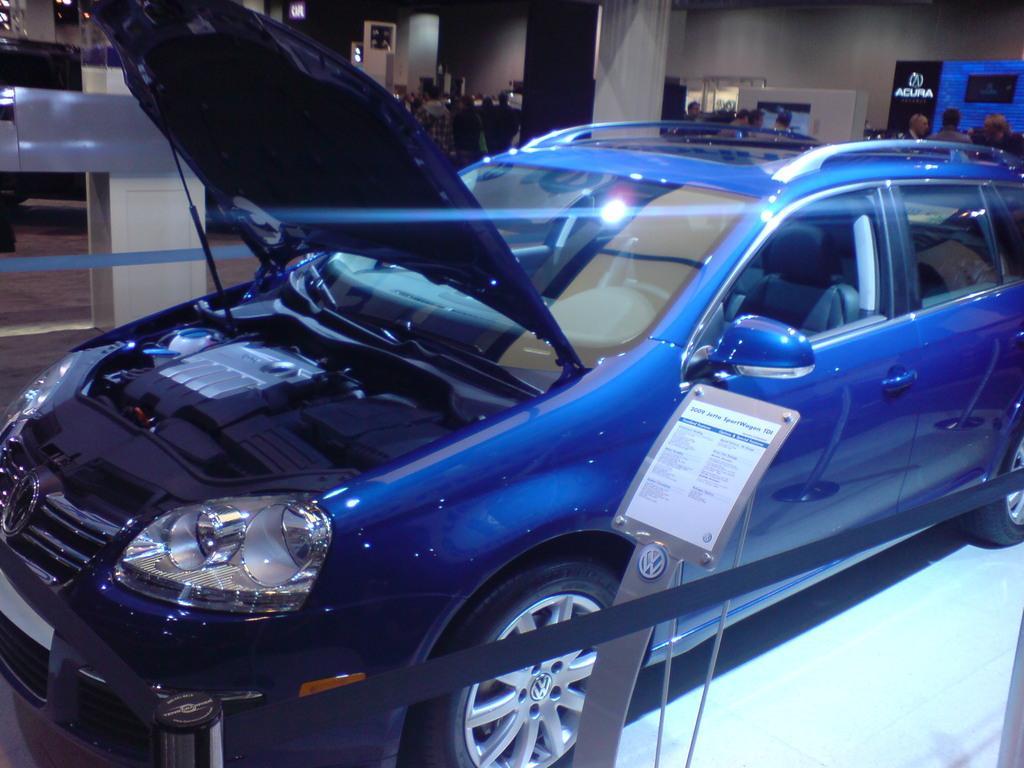Describe this image in one or two sentences. There is a blue color car. Near to that there is a board with a pole. Also there are poles with ropes. In the back there are many people, pillar and walls. 